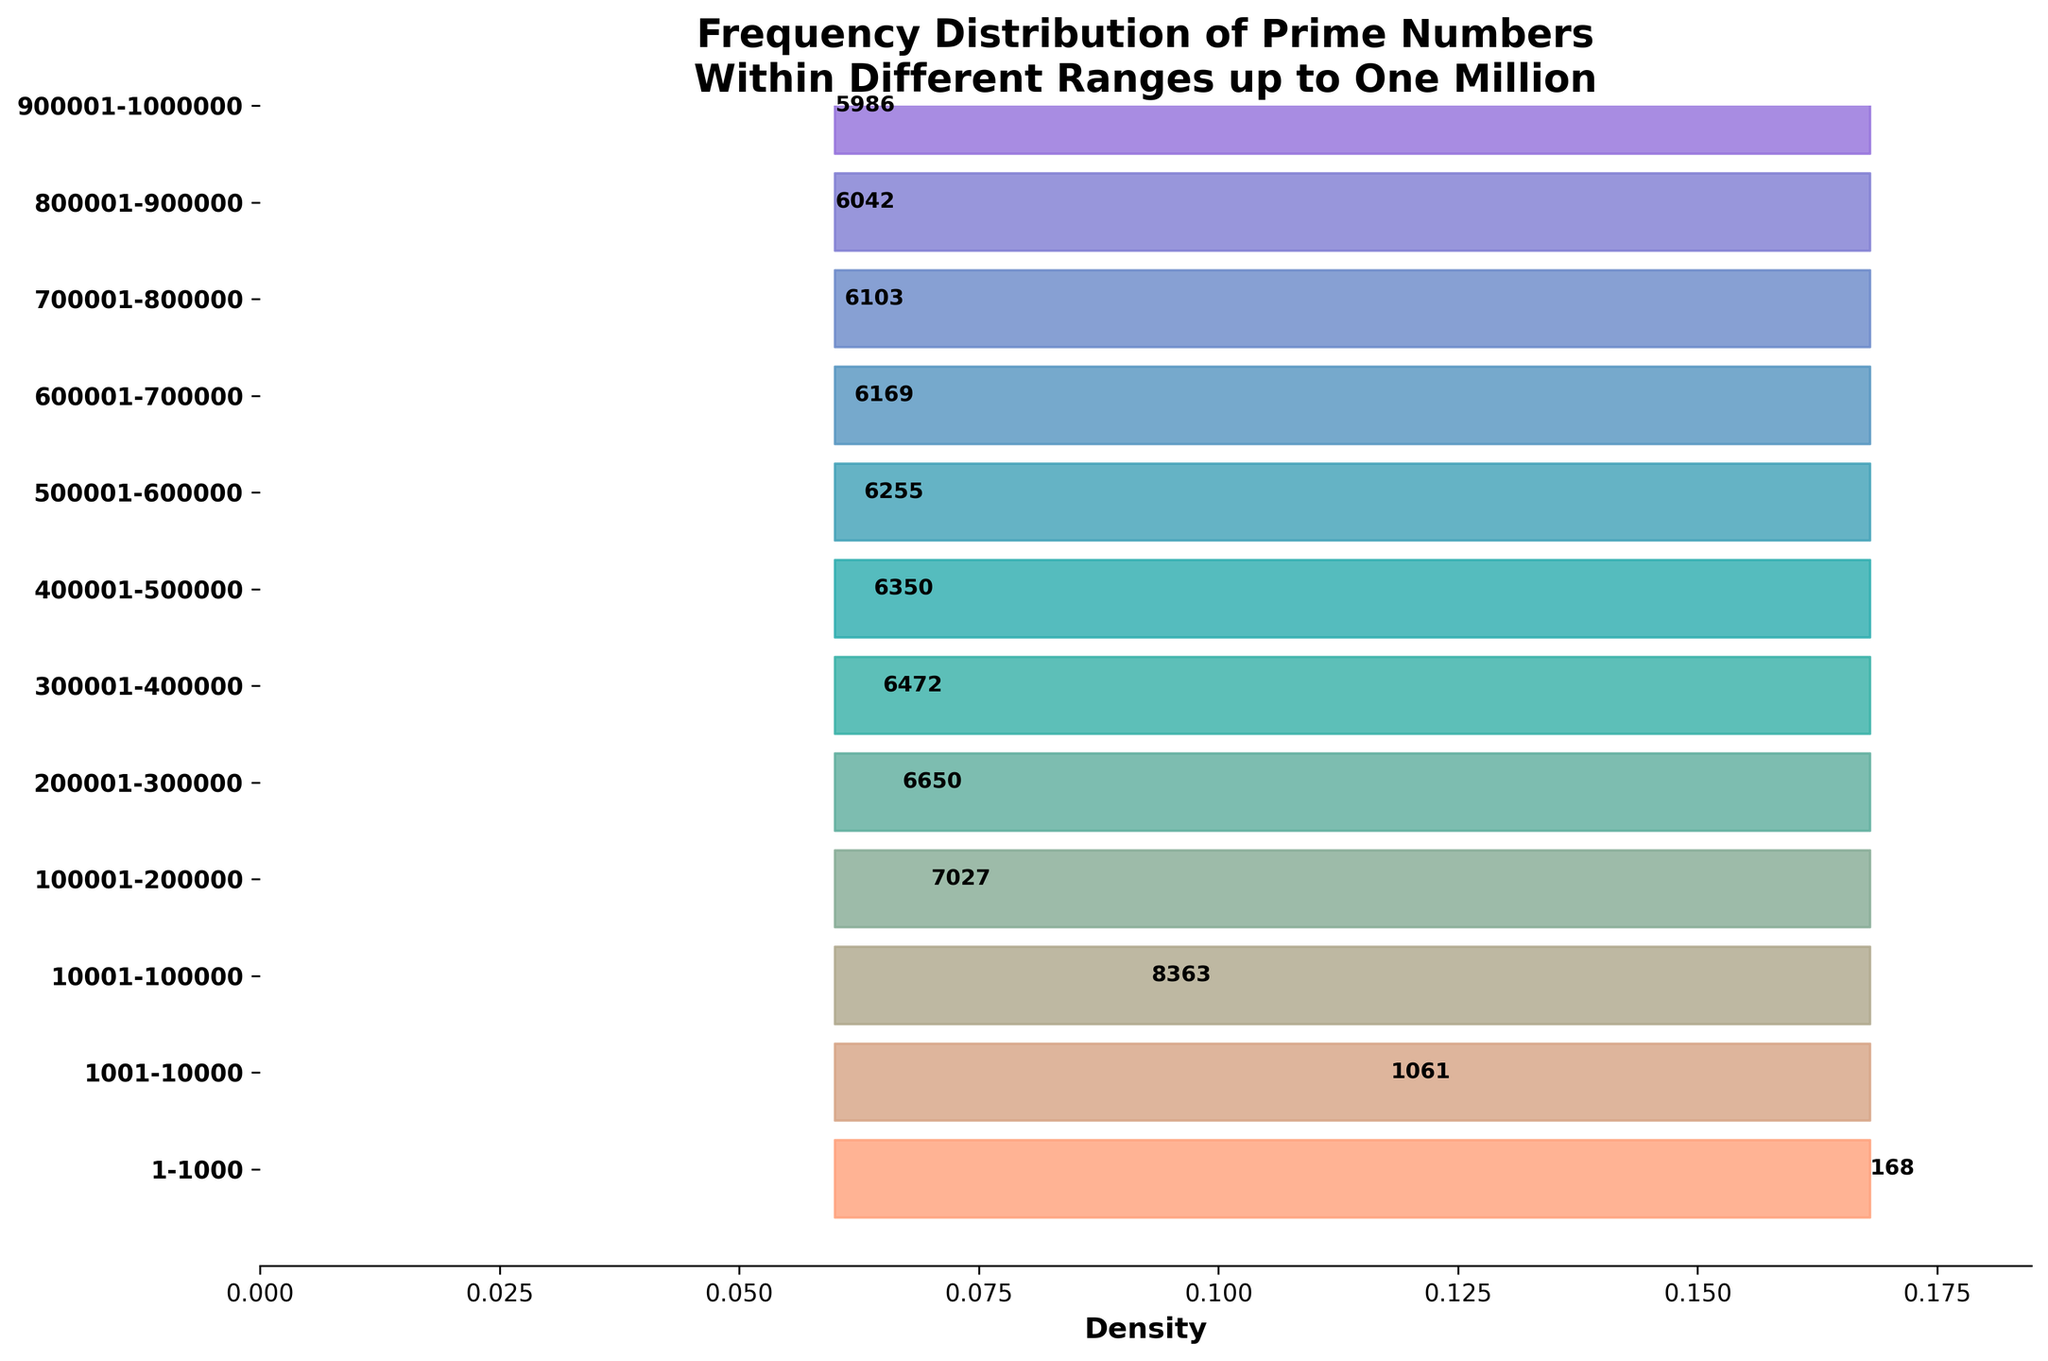What is the title of the figure? The title is located at the top of the plot and summarizes the topic of the figure.
Answer: Frequency Distribution of Prime Numbers Within Different Ranges up to One Million Which range has the highest number of primes? The range with the highest number of primes will have the highest value in the Density annotations.
Answer: 1001-10000 What is the x-axis label in the plot? The x-axis label describes what the x-axis values represent.
Answer: Density What is the value of the Density for the range 800001-900000? The Density value for each range is annotated next to the corresponding filled area on the plot. Find the annotation next to the range 800001-900000.
Answer: 0.060 How many ranges have a Density greater than 0.065? Identify all the ranges with a Density value greater than 0.065 from the annotations next to each range.
Answer: 3 Compare the Density values for the ranges 1-1000 and 700001-800000. Which range has a higher Density? Look at the Density annotations for both ranges and compare the values.
Answer: 1-1000 Are there any ranges with the same Density value? If yes, name one such pair. Check if any ranges have identical Density annotations.
Answer: 800001-900000 and 900001-1000000 What is the sum of the Frequency values for the ranges 1-1000 and 100001-200000? Add the Frequency values from both ranges: 168 (1-1000) + 7027 (100001-200000).
Answer: 7195 Which range has the least Density value, and what is that value? Identify the range with the smallest Density annotation value.
Answer: 900001-1000000, 0.060 